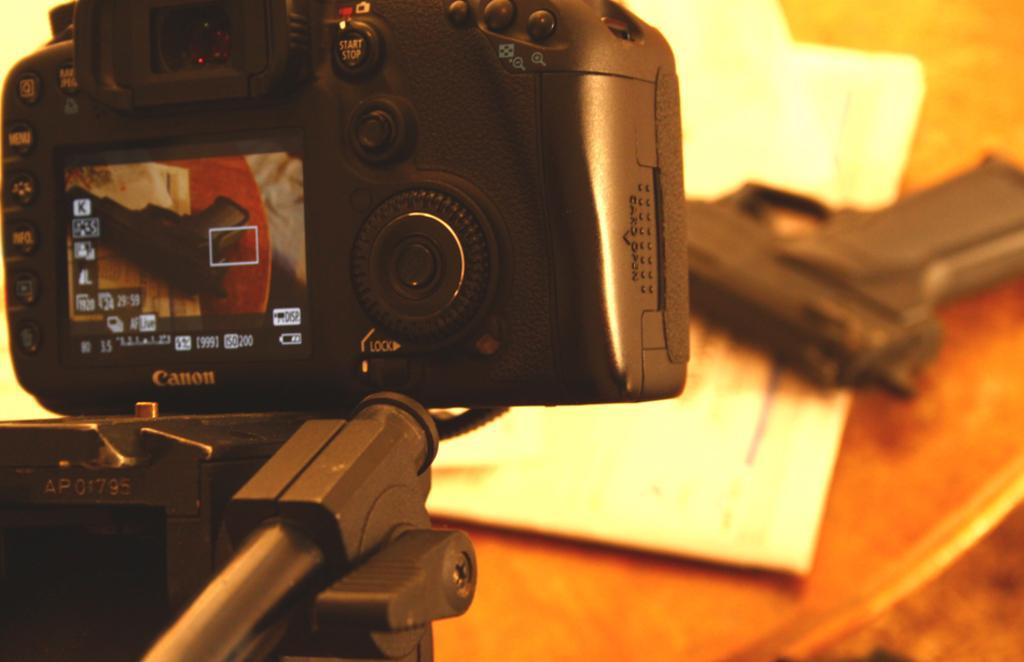Could you give a brief overview of what you see in this image? In this image in the front there is a camera with some text written on it which is on the stand which is black in colour. In the background there is a table and on the table there is a gun and there are papers. 